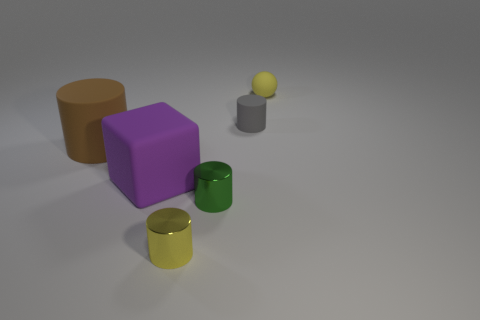Add 2 tiny spheres. How many objects exist? 8 Subtract all spheres. How many objects are left? 5 Add 3 tiny brown cubes. How many tiny brown cubes exist? 3 Subtract 0 purple spheres. How many objects are left? 6 Subtract all tiny yellow rubber spheres. Subtract all yellow objects. How many objects are left? 3 Add 6 gray matte cylinders. How many gray matte cylinders are left? 7 